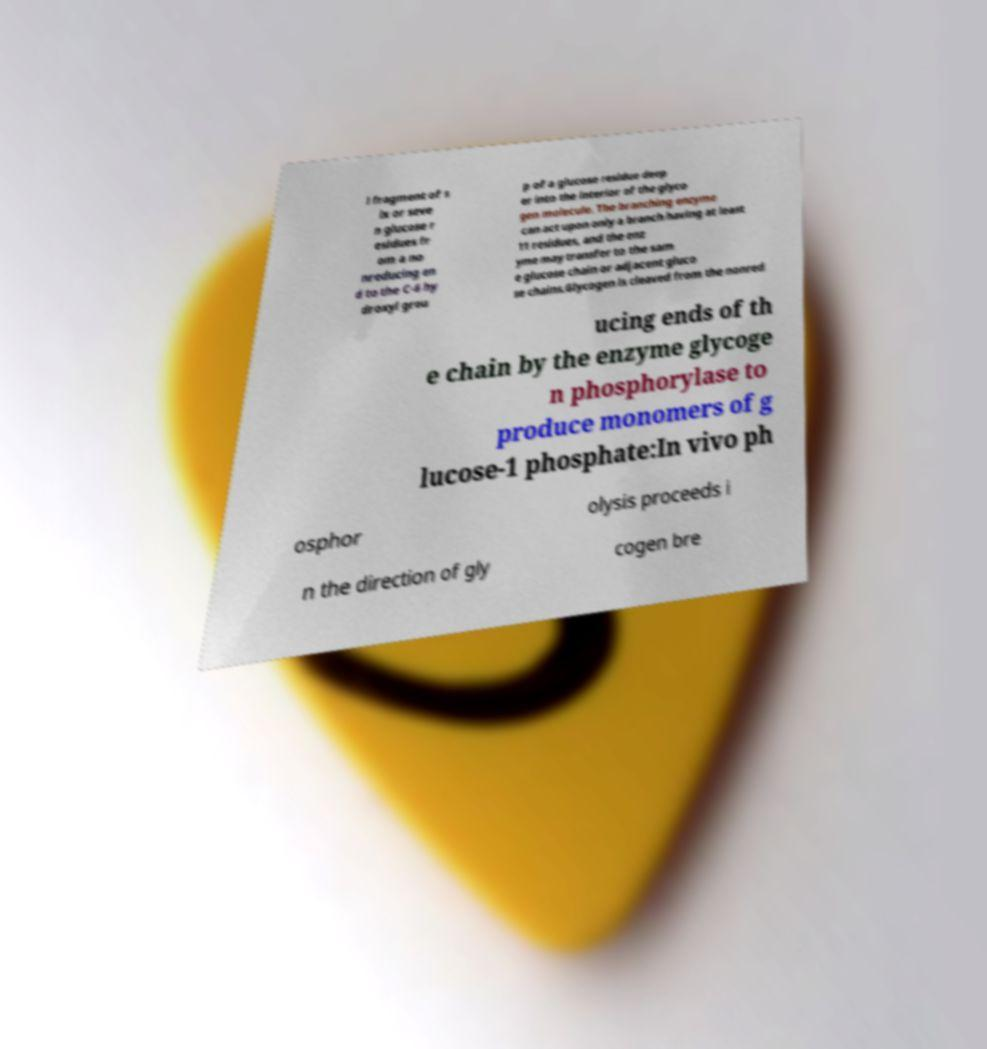For documentation purposes, I need the text within this image transcribed. Could you provide that? l fragment of s ix or seve n glucose r esidues fr om a no nreducing en d to the C-6 hy droxyl grou p of a glucose residue deep er into the interior of the glyco gen molecule. The branching enzyme can act upon only a branch having at least 11 residues, and the enz yme may transfer to the sam e glucose chain or adjacent gluco se chains.Glycogen is cleaved from the nonred ucing ends of th e chain by the enzyme glycoge n phosphorylase to produce monomers of g lucose-1 phosphate:In vivo ph osphor olysis proceeds i n the direction of gly cogen bre 